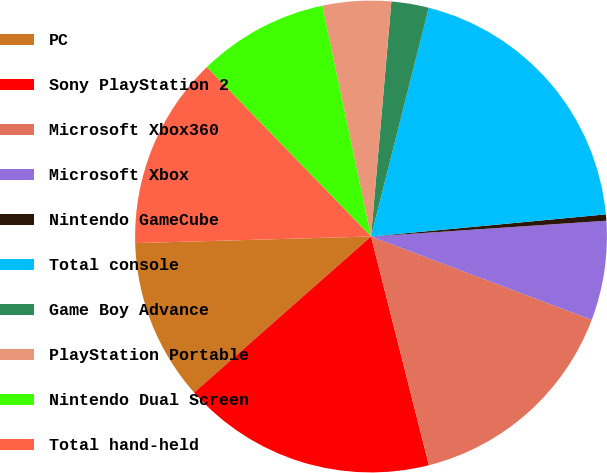Convert chart. <chart><loc_0><loc_0><loc_500><loc_500><pie_chart><fcel>PC<fcel>Sony PlayStation 2<fcel>Microsoft Xbox360<fcel>Microsoft Xbox<fcel>Nintendo GameCube<fcel>Total console<fcel>Game Boy Advance<fcel>PlayStation Portable<fcel>Nintendo Dual Screen<fcel>Total hand-held<nl><fcel>11.06%<fcel>17.44%<fcel>15.31%<fcel>6.81%<fcel>0.43%<fcel>19.57%<fcel>2.56%<fcel>4.69%<fcel>8.94%<fcel>13.19%<nl></chart> 